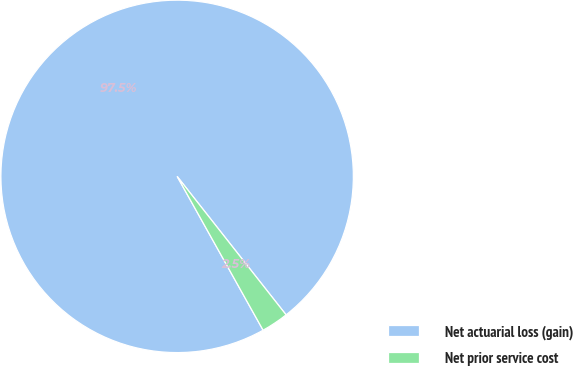Convert chart to OTSL. <chart><loc_0><loc_0><loc_500><loc_500><pie_chart><fcel>Net actuarial loss (gain)<fcel>Net prior service cost<nl><fcel>97.5%<fcel>2.5%<nl></chart> 